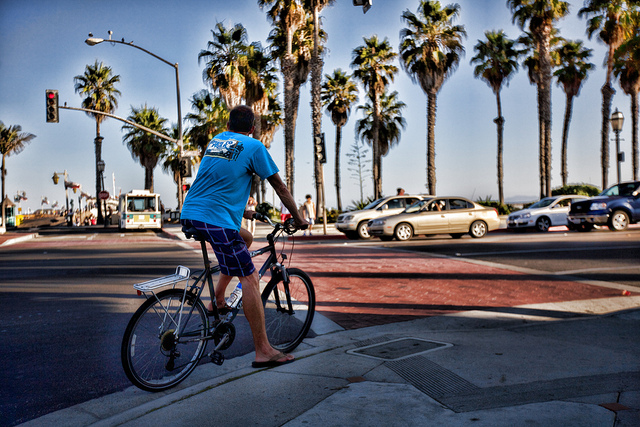Based on the image, what can you infer about the time of day? Considering the length and angle of the shadows cast by the palm trees and the cycling person, as well as the overall brightness of the scene, it can be inferred that the image was taken either late in the morning or in the afternoon, before the sunlight begins to dim towards evening. 